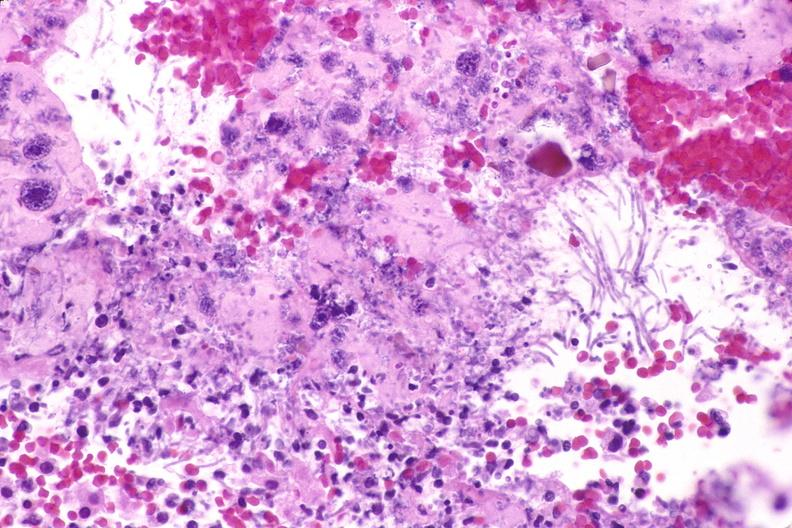s gastrointestinal present?
Answer the question using a single word or phrase. Yes 